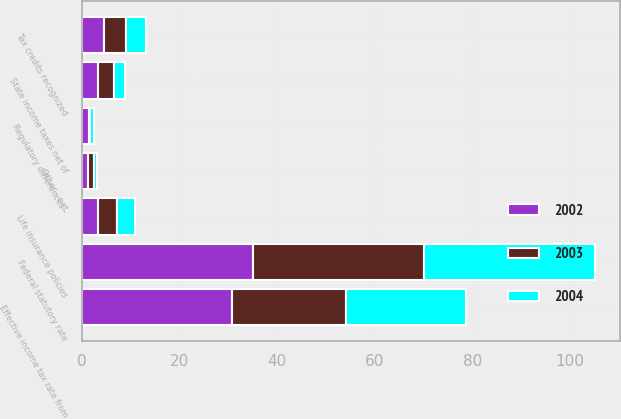Convert chart. <chart><loc_0><loc_0><loc_500><loc_500><stacked_bar_chart><ecel><fcel>Federal statutory rate<fcel>State income taxes net of<fcel>Life insurance policies<fcel>Tax credits recognized<fcel>Regulatory differences -<fcel>Other - net<fcel>Effective income tax rate from<nl><fcel>2003<fcel>35<fcel>3.3<fcel>4<fcel>4.5<fcel>0.1<fcel>1.2<fcel>23.2<nl><fcel>2004<fcel>35<fcel>2.2<fcel>3.7<fcel>4<fcel>0.8<fcel>0.7<fcel>24.6<nl><fcel>2002<fcel>35<fcel>3.2<fcel>3.2<fcel>4.5<fcel>1.5<fcel>1.2<fcel>30.8<nl></chart> 